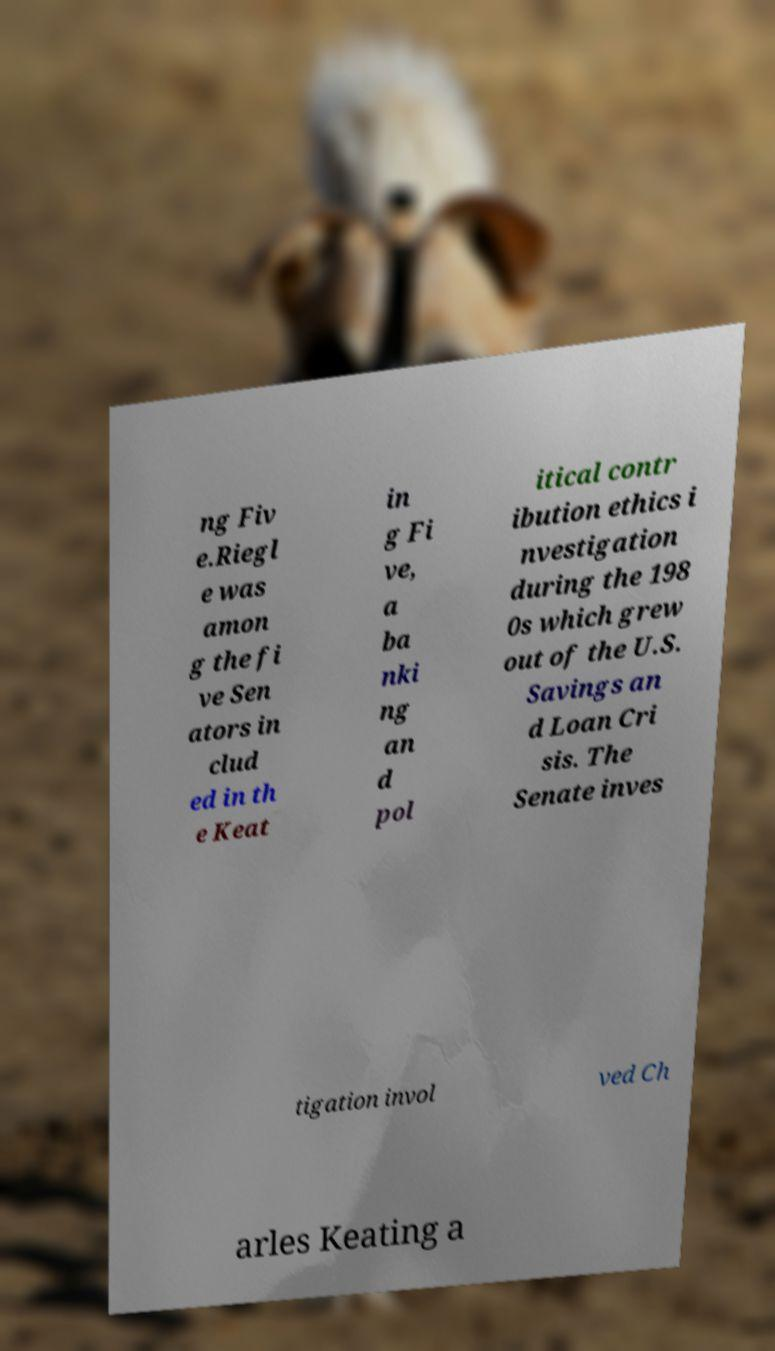Can you accurately transcribe the text from the provided image for me? ng Fiv e.Riegl e was amon g the fi ve Sen ators in clud ed in th e Keat in g Fi ve, a ba nki ng an d pol itical contr ibution ethics i nvestigation during the 198 0s which grew out of the U.S. Savings an d Loan Cri sis. The Senate inves tigation invol ved Ch arles Keating a 